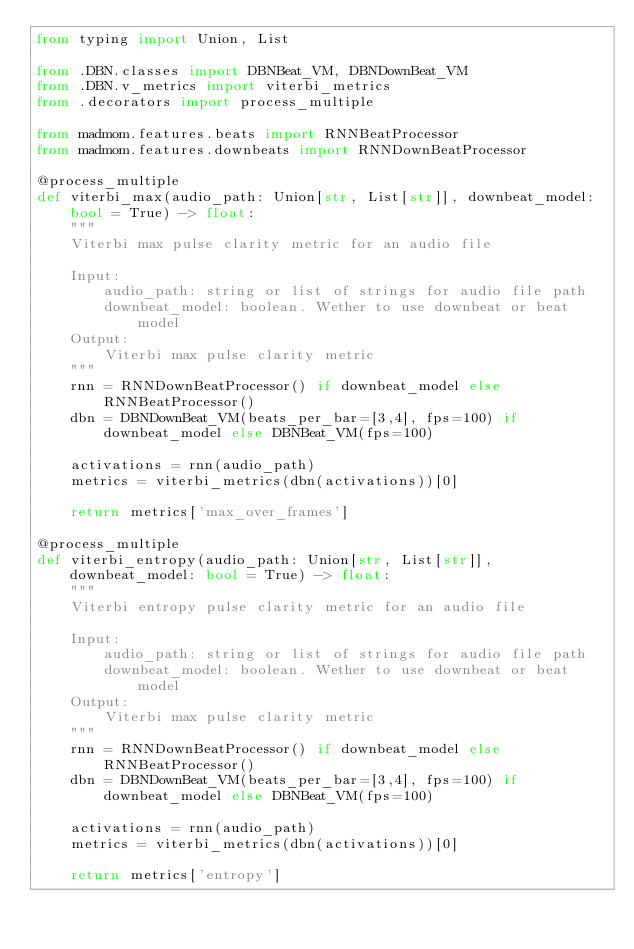<code> <loc_0><loc_0><loc_500><loc_500><_Python_>from typing import Union, List

from .DBN.classes import DBNBeat_VM, DBNDownBeat_VM
from .DBN.v_metrics import viterbi_metrics
from .decorators import process_multiple

from madmom.features.beats import RNNBeatProcessor
from madmom.features.downbeats import RNNDownBeatProcessor

@process_multiple
def viterbi_max(audio_path: Union[str, List[str]], downbeat_model: bool = True) -> float:
	""" 
	Viterbi max pulse clarity metric for an audio file
	
	Input:
		audio_path: string or list of strings for audio file path
		downbeat_model: boolean. Wether to use downbeat or beat model  
	Output: 
		Viterbi max pulse clarity metric
	"""
	rnn = RNNDownBeatProcessor() if downbeat_model else RNNBeatProcessor()
	dbn = DBNDownBeat_VM(beats_per_bar=[3,4], fps=100) if downbeat_model else DBNBeat_VM(fps=100)

	activations = rnn(audio_path)
	metrics = viterbi_metrics(dbn(activations))[0]

	return metrics['max_over_frames']

@process_multiple
def viterbi_entropy(audio_path: Union[str, List[str]], downbeat_model: bool = True) -> float:
	""" 
	Viterbi entropy pulse clarity metric for an audio file
	
	Input:
		audio_path: string or list of strings for audio file path
		downbeat_model: boolean. Wether to use downbeat or beat model  
	Output: 
		Viterbi max pulse clarity metric
	"""
	rnn = RNNDownBeatProcessor() if downbeat_model else RNNBeatProcessor()
	dbn = DBNDownBeat_VM(beats_per_bar=[3,4], fps=100) if downbeat_model else DBNBeat_VM(fps=100)

	activations = rnn(audio_path)
	metrics = viterbi_metrics(dbn(activations))[0]

	return metrics['entropy']

</code> 